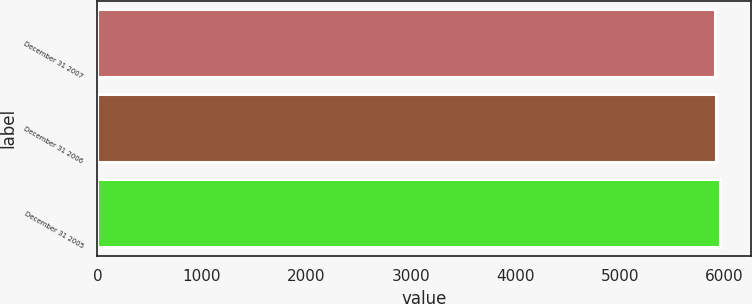<chart> <loc_0><loc_0><loc_500><loc_500><bar_chart><fcel>December 31 2007<fcel>December 31 2006<fcel>December 31 2005<nl><fcel>5910.9<fcel>5921.5<fcel>5955.4<nl></chart> 